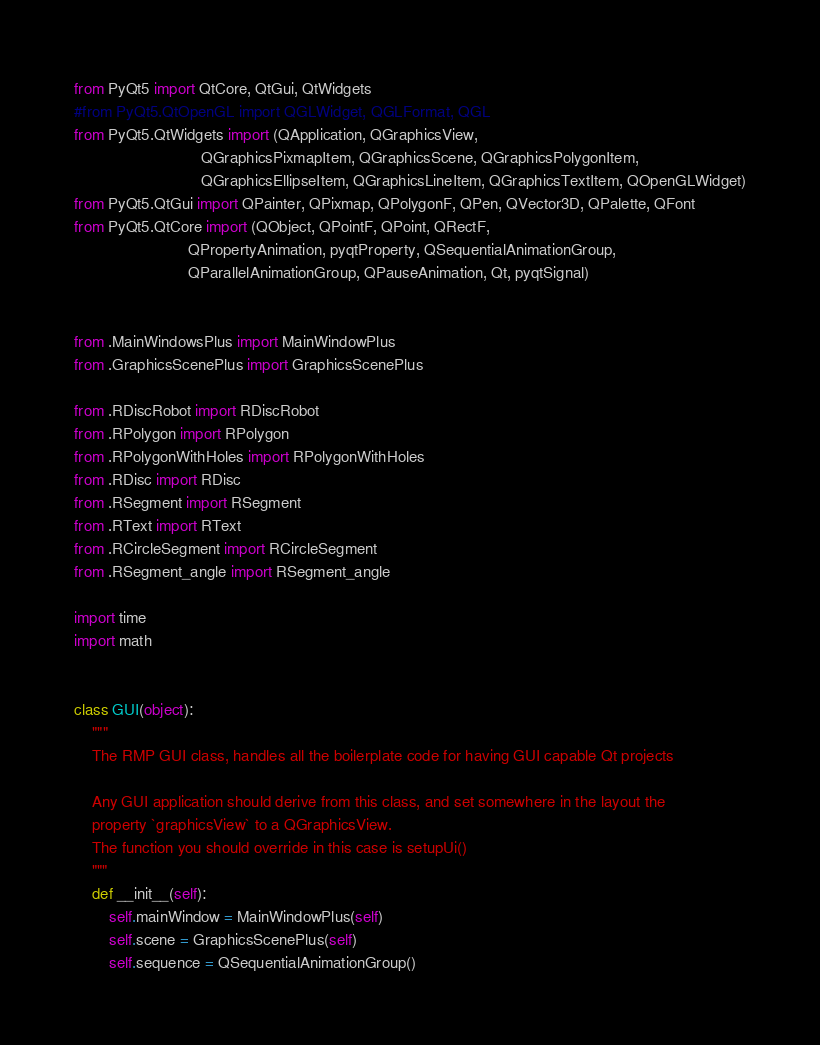Convert code to text. <code><loc_0><loc_0><loc_500><loc_500><_Python_>from PyQt5 import QtCore, QtGui, QtWidgets
#from PyQt5.QtOpenGL import QGLWidget, QGLFormat, QGL
from PyQt5.QtWidgets import (QApplication, QGraphicsView,
                             QGraphicsPixmapItem, QGraphicsScene, QGraphicsPolygonItem,
                             QGraphicsEllipseItem, QGraphicsLineItem, QGraphicsTextItem, QOpenGLWidget)
from PyQt5.QtGui import QPainter, QPixmap, QPolygonF, QPen, QVector3D, QPalette, QFont
from PyQt5.QtCore import (QObject, QPointF, QPoint, QRectF,
                          QPropertyAnimation, pyqtProperty, QSequentialAnimationGroup,
                          QParallelAnimationGroup, QPauseAnimation, Qt, pyqtSignal)


from .MainWindowsPlus import MainWindowPlus
from .GraphicsScenePlus import GraphicsScenePlus

from .RDiscRobot import RDiscRobot
from .RPolygon import RPolygon
from .RPolygonWithHoles import RPolygonWithHoles
from .RDisc import RDisc
from .RSegment import RSegment
from .RText import RText
from .RCircleSegment import RCircleSegment
from .RSegment_angle import RSegment_angle

import time
import math


class GUI(object):
    """
    The RMP GUI class, handles all the boilerplate code for having GUI capable Qt projects

    Any GUI application should derive from this class, and set somewhere in the layout the
    property `graphicsView` to a QGraphicsView.
    The function you should override in this case is setupUi()
    """
    def __init__(self):
        self.mainWindow = MainWindowPlus(self)
        self.scene = GraphicsScenePlus(self)
        self.sequence = QSequentialAnimationGroup()</code> 